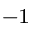Convert formula to latex. <formula><loc_0><loc_0><loc_500><loc_500>^ { - 1 }</formula> 